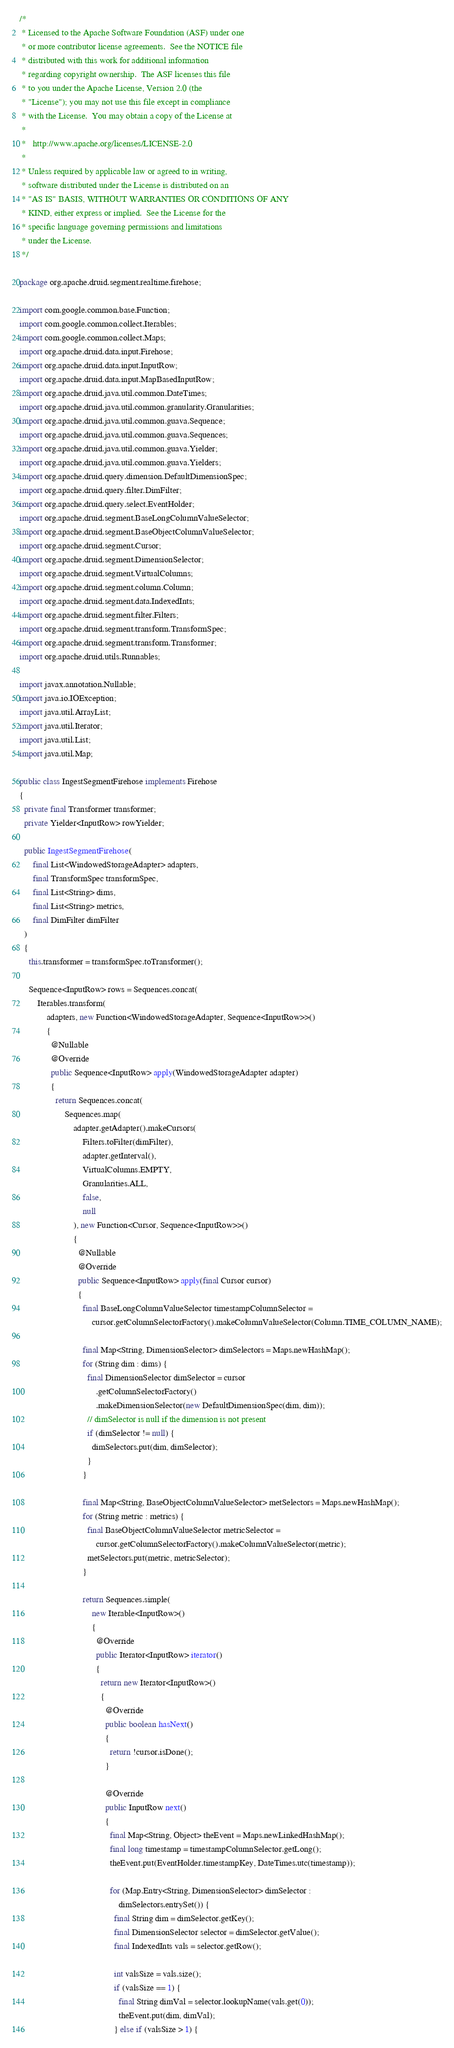<code> <loc_0><loc_0><loc_500><loc_500><_Java_>/*
 * Licensed to the Apache Software Foundation (ASF) under one
 * or more contributor license agreements.  See the NOTICE file
 * distributed with this work for additional information
 * regarding copyright ownership.  The ASF licenses this file
 * to you under the Apache License, Version 2.0 (the
 * "License"); you may not use this file except in compliance
 * with the License.  You may obtain a copy of the License at
 *
 *   http://www.apache.org/licenses/LICENSE-2.0
 *
 * Unless required by applicable law or agreed to in writing,
 * software distributed under the License is distributed on an
 * "AS IS" BASIS, WITHOUT WARRANTIES OR CONDITIONS OF ANY
 * KIND, either express or implied.  See the License for the
 * specific language governing permissions and limitations
 * under the License.
 */

package org.apache.druid.segment.realtime.firehose;

import com.google.common.base.Function;
import com.google.common.collect.Iterables;
import com.google.common.collect.Maps;
import org.apache.druid.data.input.Firehose;
import org.apache.druid.data.input.InputRow;
import org.apache.druid.data.input.MapBasedInputRow;
import org.apache.druid.java.util.common.DateTimes;
import org.apache.druid.java.util.common.granularity.Granularities;
import org.apache.druid.java.util.common.guava.Sequence;
import org.apache.druid.java.util.common.guava.Sequences;
import org.apache.druid.java.util.common.guava.Yielder;
import org.apache.druid.java.util.common.guava.Yielders;
import org.apache.druid.query.dimension.DefaultDimensionSpec;
import org.apache.druid.query.filter.DimFilter;
import org.apache.druid.query.select.EventHolder;
import org.apache.druid.segment.BaseLongColumnValueSelector;
import org.apache.druid.segment.BaseObjectColumnValueSelector;
import org.apache.druid.segment.Cursor;
import org.apache.druid.segment.DimensionSelector;
import org.apache.druid.segment.VirtualColumns;
import org.apache.druid.segment.column.Column;
import org.apache.druid.segment.data.IndexedInts;
import org.apache.druid.segment.filter.Filters;
import org.apache.druid.segment.transform.TransformSpec;
import org.apache.druid.segment.transform.Transformer;
import org.apache.druid.utils.Runnables;

import javax.annotation.Nullable;
import java.io.IOException;
import java.util.ArrayList;
import java.util.Iterator;
import java.util.List;
import java.util.Map;

public class IngestSegmentFirehose implements Firehose
{
  private final Transformer transformer;
  private Yielder<InputRow> rowYielder;

  public IngestSegmentFirehose(
      final List<WindowedStorageAdapter> adapters,
      final TransformSpec transformSpec,
      final List<String> dims,
      final List<String> metrics,
      final DimFilter dimFilter
  )
  {
    this.transformer = transformSpec.toTransformer();

    Sequence<InputRow> rows = Sequences.concat(
        Iterables.transform(
            adapters, new Function<WindowedStorageAdapter, Sequence<InputRow>>()
            {
              @Nullable
              @Override
              public Sequence<InputRow> apply(WindowedStorageAdapter adapter)
              {
                return Sequences.concat(
                    Sequences.map(
                        adapter.getAdapter().makeCursors(
                            Filters.toFilter(dimFilter),
                            adapter.getInterval(),
                            VirtualColumns.EMPTY,
                            Granularities.ALL,
                            false,
                            null
                        ), new Function<Cursor, Sequence<InputRow>>()
                        {
                          @Nullable
                          @Override
                          public Sequence<InputRow> apply(final Cursor cursor)
                          {
                            final BaseLongColumnValueSelector timestampColumnSelector =
                                cursor.getColumnSelectorFactory().makeColumnValueSelector(Column.TIME_COLUMN_NAME);

                            final Map<String, DimensionSelector> dimSelectors = Maps.newHashMap();
                            for (String dim : dims) {
                              final DimensionSelector dimSelector = cursor
                                  .getColumnSelectorFactory()
                                  .makeDimensionSelector(new DefaultDimensionSpec(dim, dim));
                              // dimSelector is null if the dimension is not present
                              if (dimSelector != null) {
                                dimSelectors.put(dim, dimSelector);
                              }
                            }

                            final Map<String, BaseObjectColumnValueSelector> metSelectors = Maps.newHashMap();
                            for (String metric : metrics) {
                              final BaseObjectColumnValueSelector metricSelector =
                                  cursor.getColumnSelectorFactory().makeColumnValueSelector(metric);
                              metSelectors.put(metric, metricSelector);
                            }

                            return Sequences.simple(
                                new Iterable<InputRow>()
                                {
                                  @Override
                                  public Iterator<InputRow> iterator()
                                  {
                                    return new Iterator<InputRow>()
                                    {
                                      @Override
                                      public boolean hasNext()
                                      {
                                        return !cursor.isDone();
                                      }

                                      @Override
                                      public InputRow next()
                                      {
                                        final Map<String, Object> theEvent = Maps.newLinkedHashMap();
                                        final long timestamp = timestampColumnSelector.getLong();
                                        theEvent.put(EventHolder.timestampKey, DateTimes.utc(timestamp));

                                        for (Map.Entry<String, DimensionSelector> dimSelector :
                                            dimSelectors.entrySet()) {
                                          final String dim = dimSelector.getKey();
                                          final DimensionSelector selector = dimSelector.getValue();
                                          final IndexedInts vals = selector.getRow();

                                          int valsSize = vals.size();
                                          if (valsSize == 1) {
                                            final String dimVal = selector.lookupName(vals.get(0));
                                            theEvent.put(dim, dimVal);
                                          } else if (valsSize > 1) {</code> 